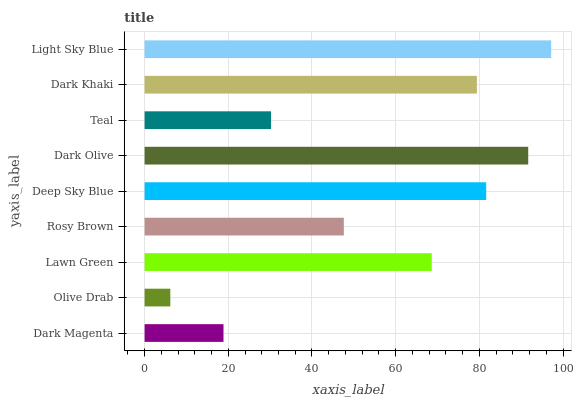Is Olive Drab the minimum?
Answer yes or no. Yes. Is Light Sky Blue the maximum?
Answer yes or no. Yes. Is Lawn Green the minimum?
Answer yes or no. No. Is Lawn Green the maximum?
Answer yes or no. No. Is Lawn Green greater than Olive Drab?
Answer yes or no. Yes. Is Olive Drab less than Lawn Green?
Answer yes or no. Yes. Is Olive Drab greater than Lawn Green?
Answer yes or no. No. Is Lawn Green less than Olive Drab?
Answer yes or no. No. Is Lawn Green the high median?
Answer yes or no. Yes. Is Lawn Green the low median?
Answer yes or no. Yes. Is Dark Magenta the high median?
Answer yes or no. No. Is Deep Sky Blue the low median?
Answer yes or no. No. 